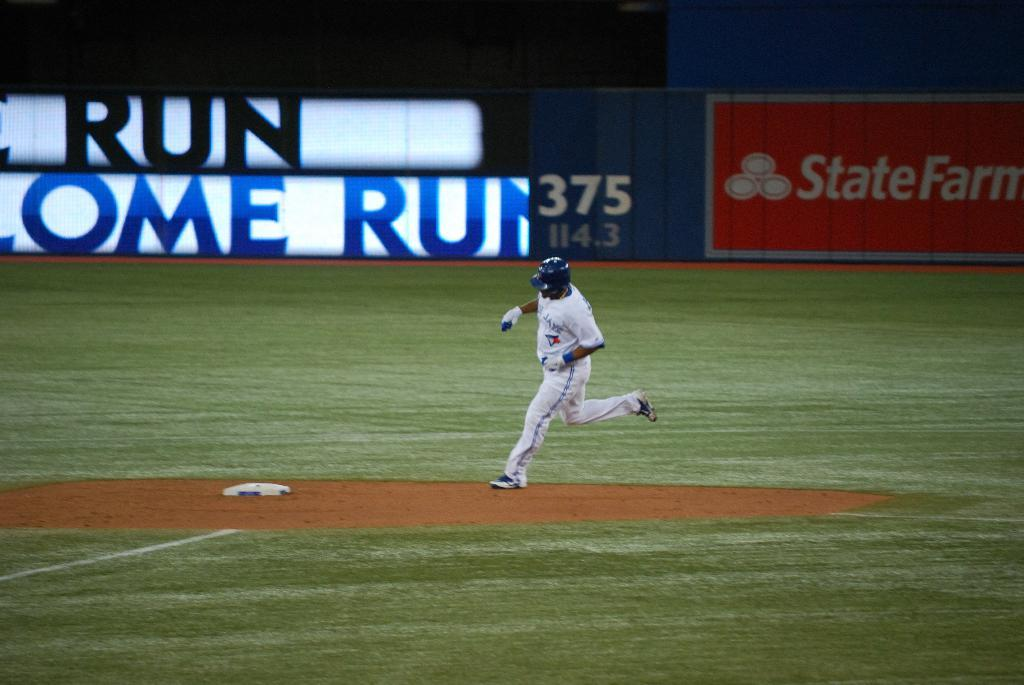<image>
Give a short and clear explanation of the subsequent image. A person on a sparts field, the word State is visible in white on red behind him. 